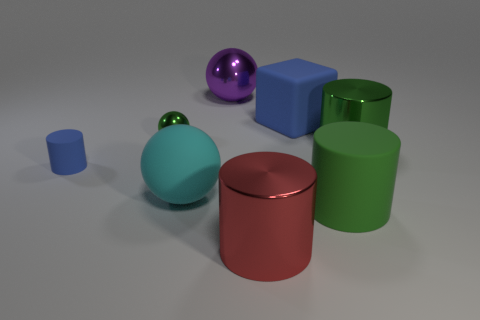Is there a purple matte thing of the same shape as the red thing?
Provide a short and direct response. No. Is the big green metallic thing the same shape as the red object?
Make the answer very short. Yes. There is a metallic cylinder right of the big metal cylinder that is in front of the tiny matte thing; what color is it?
Your answer should be compact. Green. What color is the matte block that is the same size as the red metallic cylinder?
Your answer should be compact. Blue. How many metallic objects are either small blue objects or brown cylinders?
Keep it short and to the point. 0. There is a big green matte thing on the right side of the small matte object; how many small rubber cylinders are behind it?
Offer a terse response. 1. The metal object that is the same color as the small ball is what size?
Your answer should be very brief. Large. How many objects are tiny cyan cylinders or rubber things that are in front of the tiny blue matte cylinder?
Offer a very short reply. 2. Is there a green cylinder made of the same material as the large blue block?
Provide a succinct answer. Yes. How many metallic objects are both in front of the big shiny ball and on the left side of the large red cylinder?
Offer a very short reply. 1. 